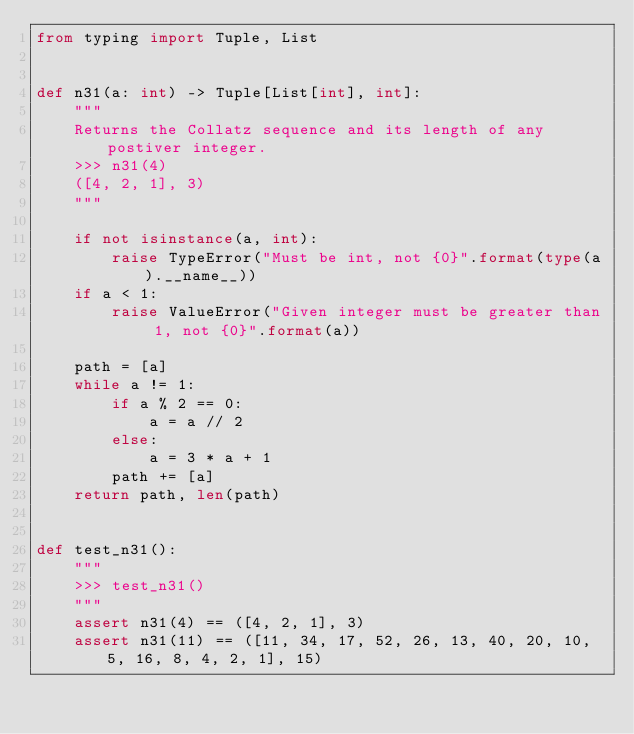Convert code to text. <code><loc_0><loc_0><loc_500><loc_500><_Python_>from typing import Tuple, List


def n31(a: int) -> Tuple[List[int], int]:
    """
    Returns the Collatz sequence and its length of any postiver integer.
    >>> n31(4)
    ([4, 2, 1], 3)
    """

    if not isinstance(a, int):
        raise TypeError("Must be int, not {0}".format(type(a).__name__))
    if a < 1:
        raise ValueError("Given integer must be greater than 1, not {0}".format(a))

    path = [a]
    while a != 1:
        if a % 2 == 0:
            a = a // 2
        else:
            a = 3 * a + 1
        path += [a]
    return path, len(path)


def test_n31():
    """
    >>> test_n31()
    """
    assert n31(4) == ([4, 2, 1], 3)
    assert n31(11) == ([11, 34, 17, 52, 26, 13, 40, 20, 10, 5, 16, 8, 4, 2, 1], 15)</code> 